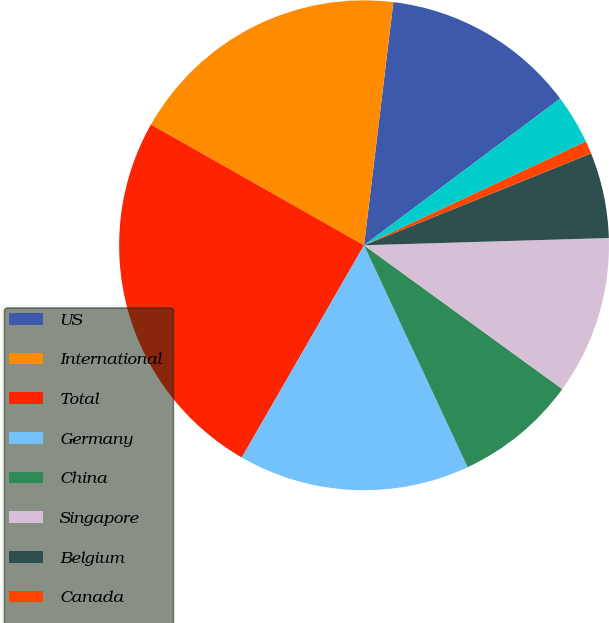<chart> <loc_0><loc_0><loc_500><loc_500><pie_chart><fcel>US<fcel>International<fcel>Total<fcel>Germany<fcel>China<fcel>Singapore<fcel>Belgium<fcel>Canada<fcel>Mexico<nl><fcel>12.87%<fcel>18.71%<fcel>24.89%<fcel>15.27%<fcel>8.06%<fcel>10.46%<fcel>5.65%<fcel>0.85%<fcel>3.25%<nl></chart> 